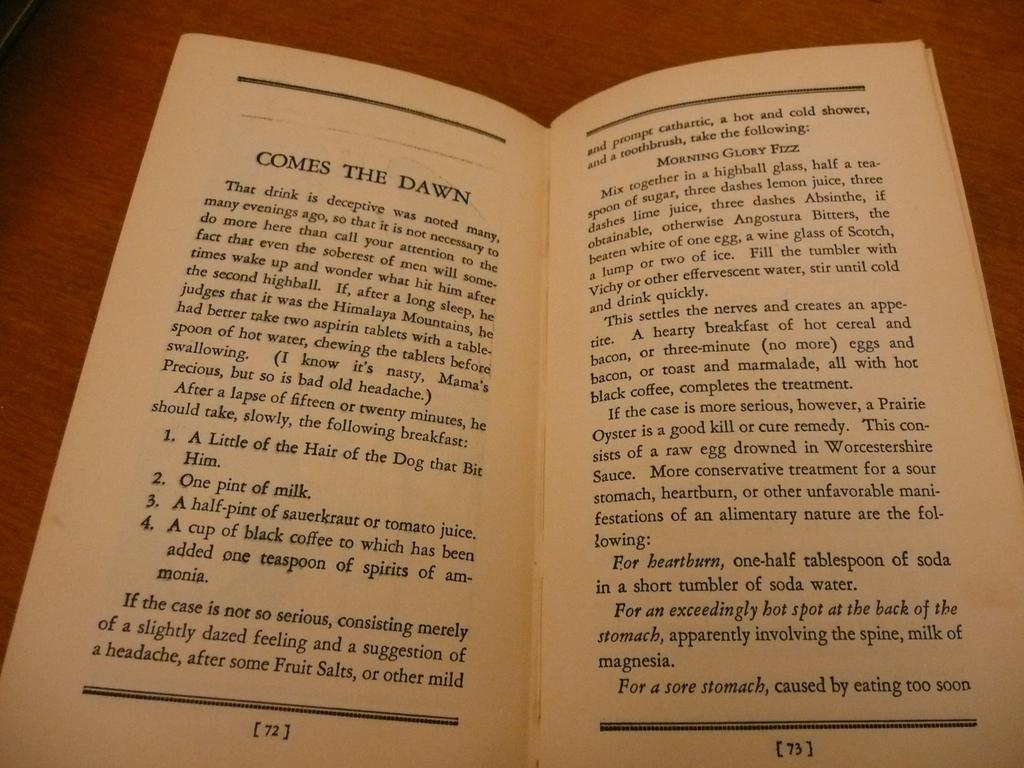<image>
Give a short and clear explanation of the subsequent image. A book on a brown talbe, lies open to pages 72-73 for the chapter titled, Comes The Dawn. 